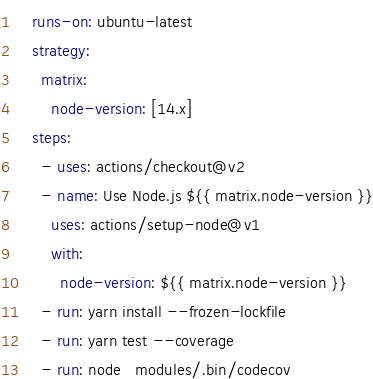<code> <loc_0><loc_0><loc_500><loc_500><_YAML_>    runs-on: ubuntu-latest
    strategy:
      matrix:
        node-version: [14.x]
    steps:
      - uses: actions/checkout@v2
      - name: Use Node.js ${{ matrix.node-version }}
        uses: actions/setup-node@v1
        with:
          node-version: ${{ matrix.node-version }}
      - run: yarn install --frozen-lockfile
      - run: yarn test --coverage
      - run: node_modules/.bin/codecov
</code> 